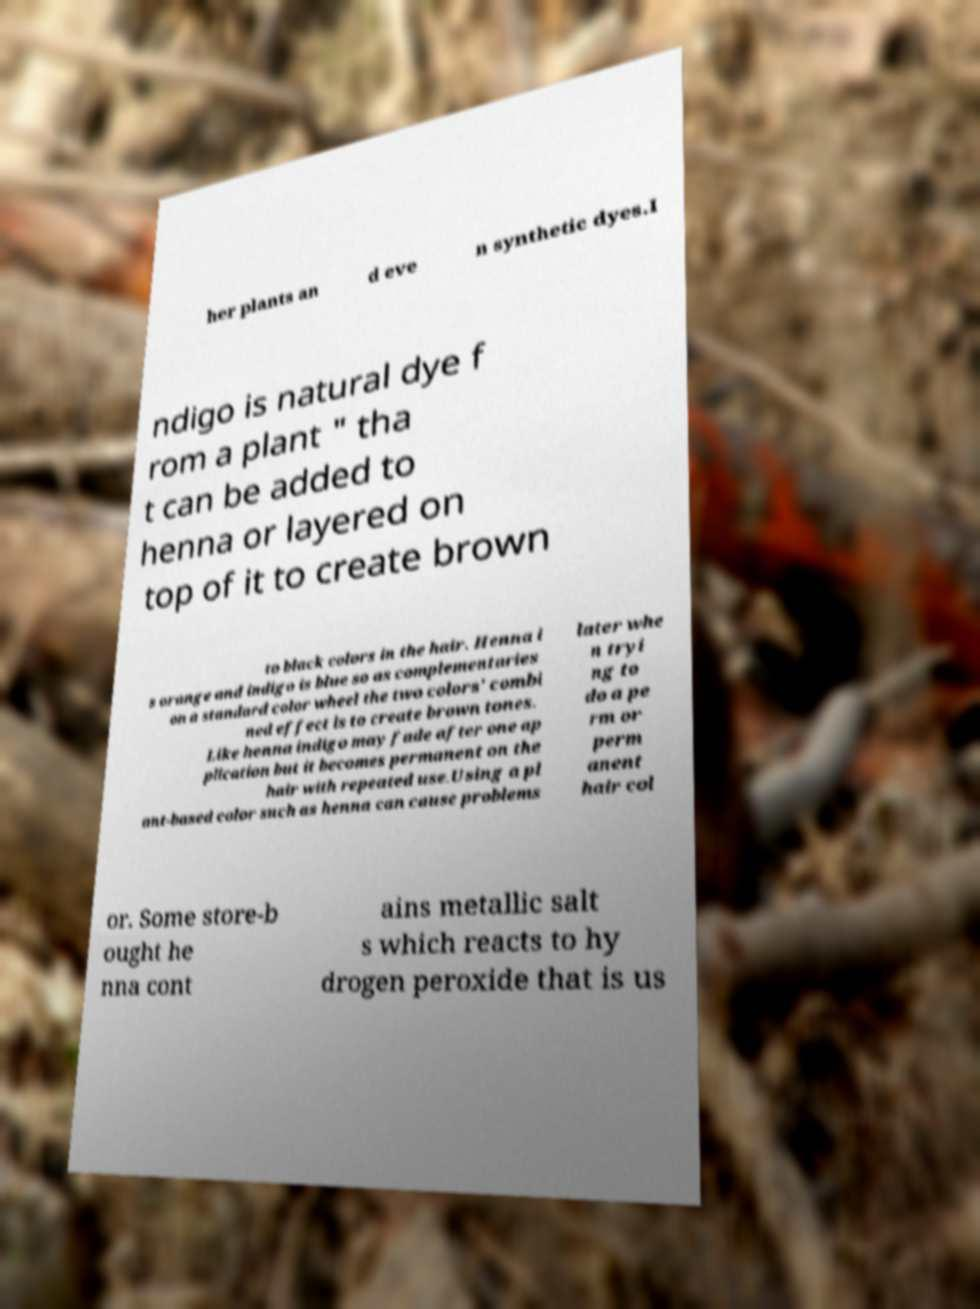Please identify and transcribe the text found in this image. her plants an d eve n synthetic dyes.I ndigo is natural dye f rom a plant " tha t can be added to henna or layered on top of it to create brown to black colors in the hair. Henna i s orange and indigo is blue so as complementaries on a standard color wheel the two colors' combi ned effect is to create brown tones. Like henna indigo may fade after one ap plication but it becomes permanent on the hair with repeated use.Using a pl ant-based color such as henna can cause problems later whe n tryi ng to do a pe rm or perm anent hair col or. Some store-b ought he nna cont ains metallic salt s which reacts to hy drogen peroxide that is us 